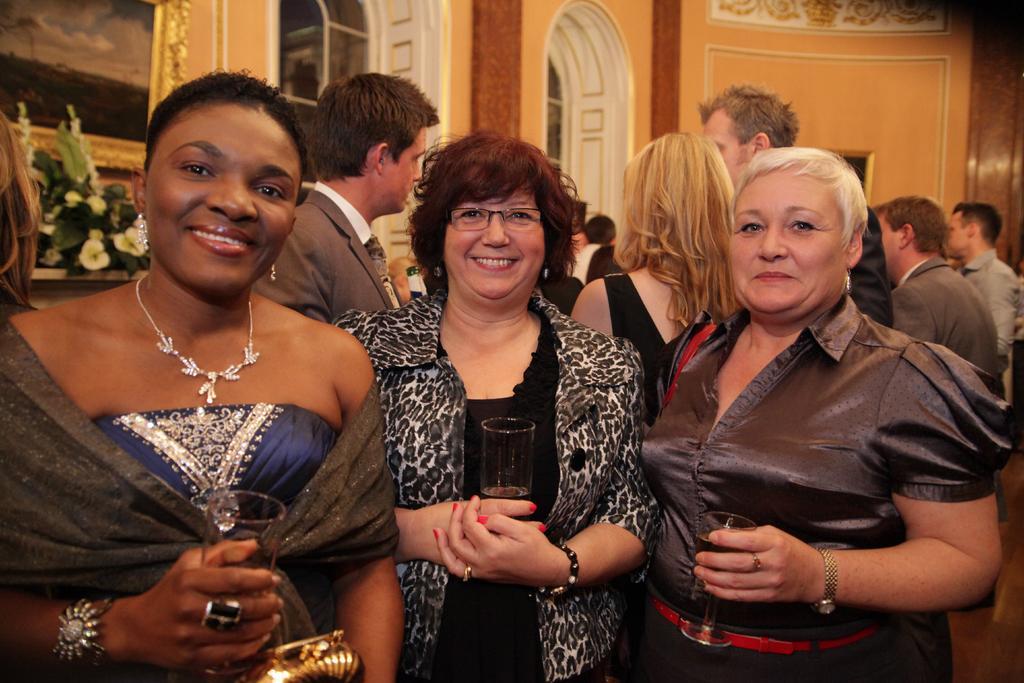In one or two sentences, can you explain what this image depicts? This image is taken indoors. In the middle of the image three women are standing on the floor and they are holding glasses with wine in their hands and they are with smiling faces. In the background a few people are standing on the floor and there are a few walls with windows and a picture frame on it and there is a bouquet. 